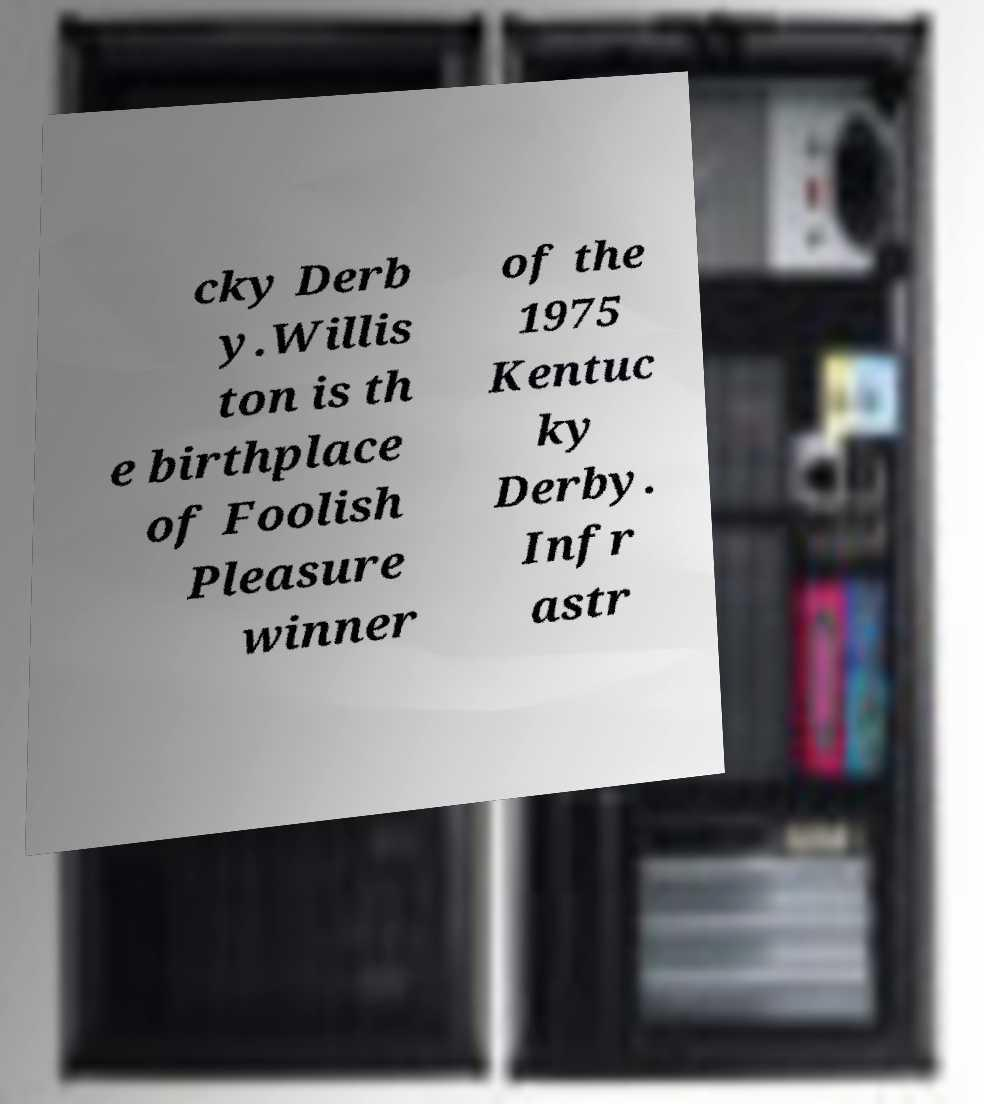Can you read and provide the text displayed in the image?This photo seems to have some interesting text. Can you extract and type it out for me? cky Derb y.Willis ton is th e birthplace of Foolish Pleasure winner of the 1975 Kentuc ky Derby. Infr astr 